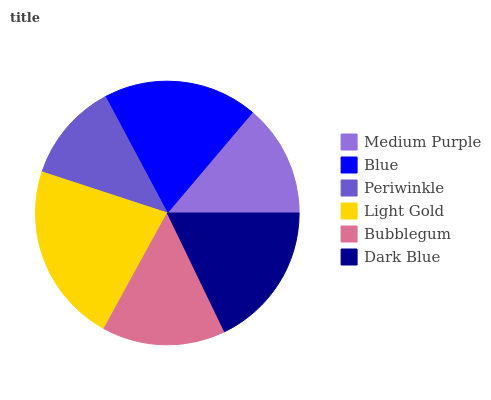Is Periwinkle the minimum?
Answer yes or no. Yes. Is Light Gold the maximum?
Answer yes or no. Yes. Is Blue the minimum?
Answer yes or no. No. Is Blue the maximum?
Answer yes or no. No. Is Blue greater than Medium Purple?
Answer yes or no. Yes. Is Medium Purple less than Blue?
Answer yes or no. Yes. Is Medium Purple greater than Blue?
Answer yes or no. No. Is Blue less than Medium Purple?
Answer yes or no. No. Is Dark Blue the high median?
Answer yes or no. Yes. Is Bubblegum the low median?
Answer yes or no. Yes. Is Light Gold the high median?
Answer yes or no. No. Is Dark Blue the low median?
Answer yes or no. No. 